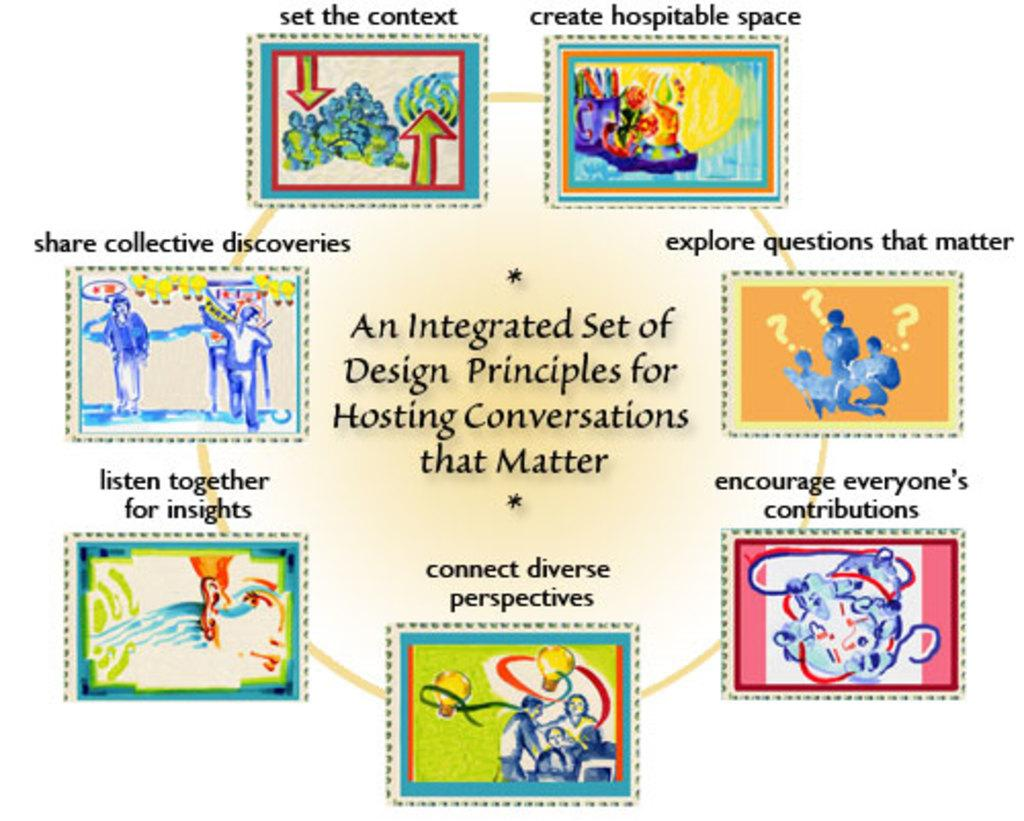<image>
Create a compact narrative representing the image presented. a colorful graph shows you how to host conversations that matter 